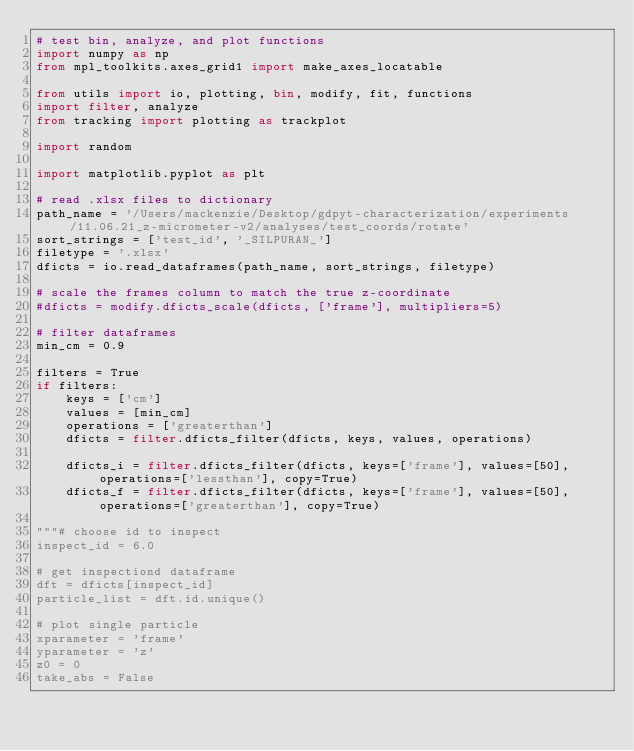Convert code to text. <code><loc_0><loc_0><loc_500><loc_500><_Python_># test bin, analyze, and plot functions
import numpy as np
from mpl_toolkits.axes_grid1 import make_axes_locatable

from utils import io, plotting, bin, modify, fit, functions
import filter, analyze
from tracking import plotting as trackplot

import random

import matplotlib.pyplot as plt

# read .xlsx files to dictionary
path_name = '/Users/mackenzie/Desktop/gdpyt-characterization/experiments/11.06.21_z-micrometer-v2/analyses/test_coords/rotate'
sort_strings = ['test_id', '_SILPURAN_']
filetype = '.xlsx'
dficts = io.read_dataframes(path_name, sort_strings, filetype)

# scale the frames column to match the true z-coordinate
#dficts = modify.dficts_scale(dficts, ['frame'], multipliers=5)

# filter dataframes
min_cm = 0.9

filters = True
if filters:
    keys = ['cm']
    values = [min_cm]
    operations = ['greaterthan']
    dficts = filter.dficts_filter(dficts, keys, values, operations)

    dficts_i = filter.dficts_filter(dficts, keys=['frame'], values=[50], operations=['lessthan'], copy=True)
    dficts_f = filter.dficts_filter(dficts, keys=['frame'], values=[50], operations=['greaterthan'], copy=True)

"""# choose id to inspect
inspect_id = 6.0

# get inspectiond dataframe
dft = dficts[inspect_id]
particle_list = dft.id.unique()

# plot single particle
xparameter = 'frame'
yparameter = 'z'
z0 = 0
take_abs = False
</code> 